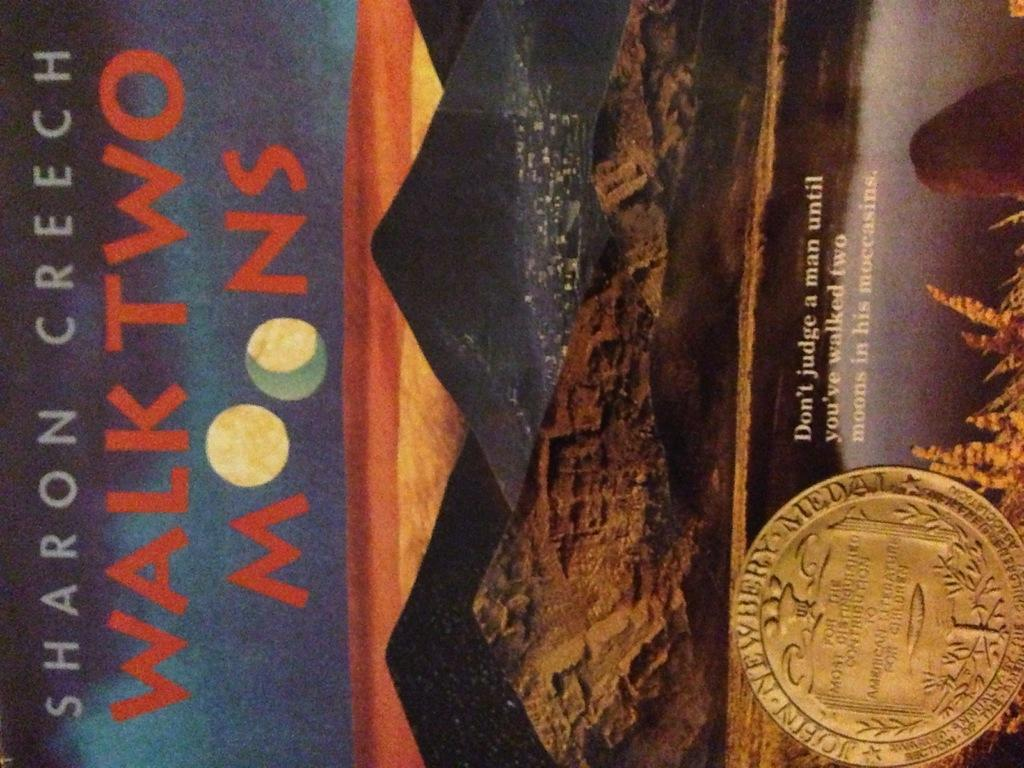<image>
Summarize the visual content of the image. A book cover of Walk Two Moons by Sharon Creech 